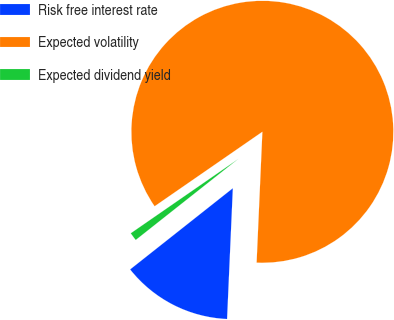<chart> <loc_0><loc_0><loc_500><loc_500><pie_chart><fcel>Risk free interest rate<fcel>Expected volatility<fcel>Expected dividend yield<nl><fcel>13.65%<fcel>85.32%<fcel>1.02%<nl></chart> 